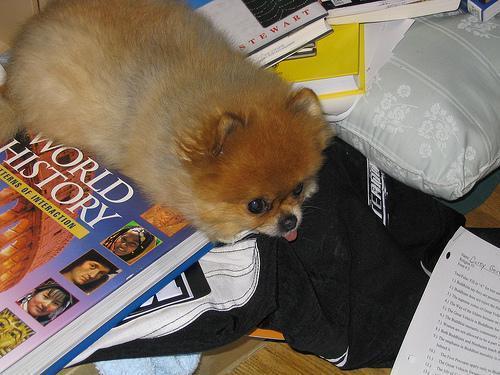How many dogs in the photo?
Give a very brief answer. 1. 